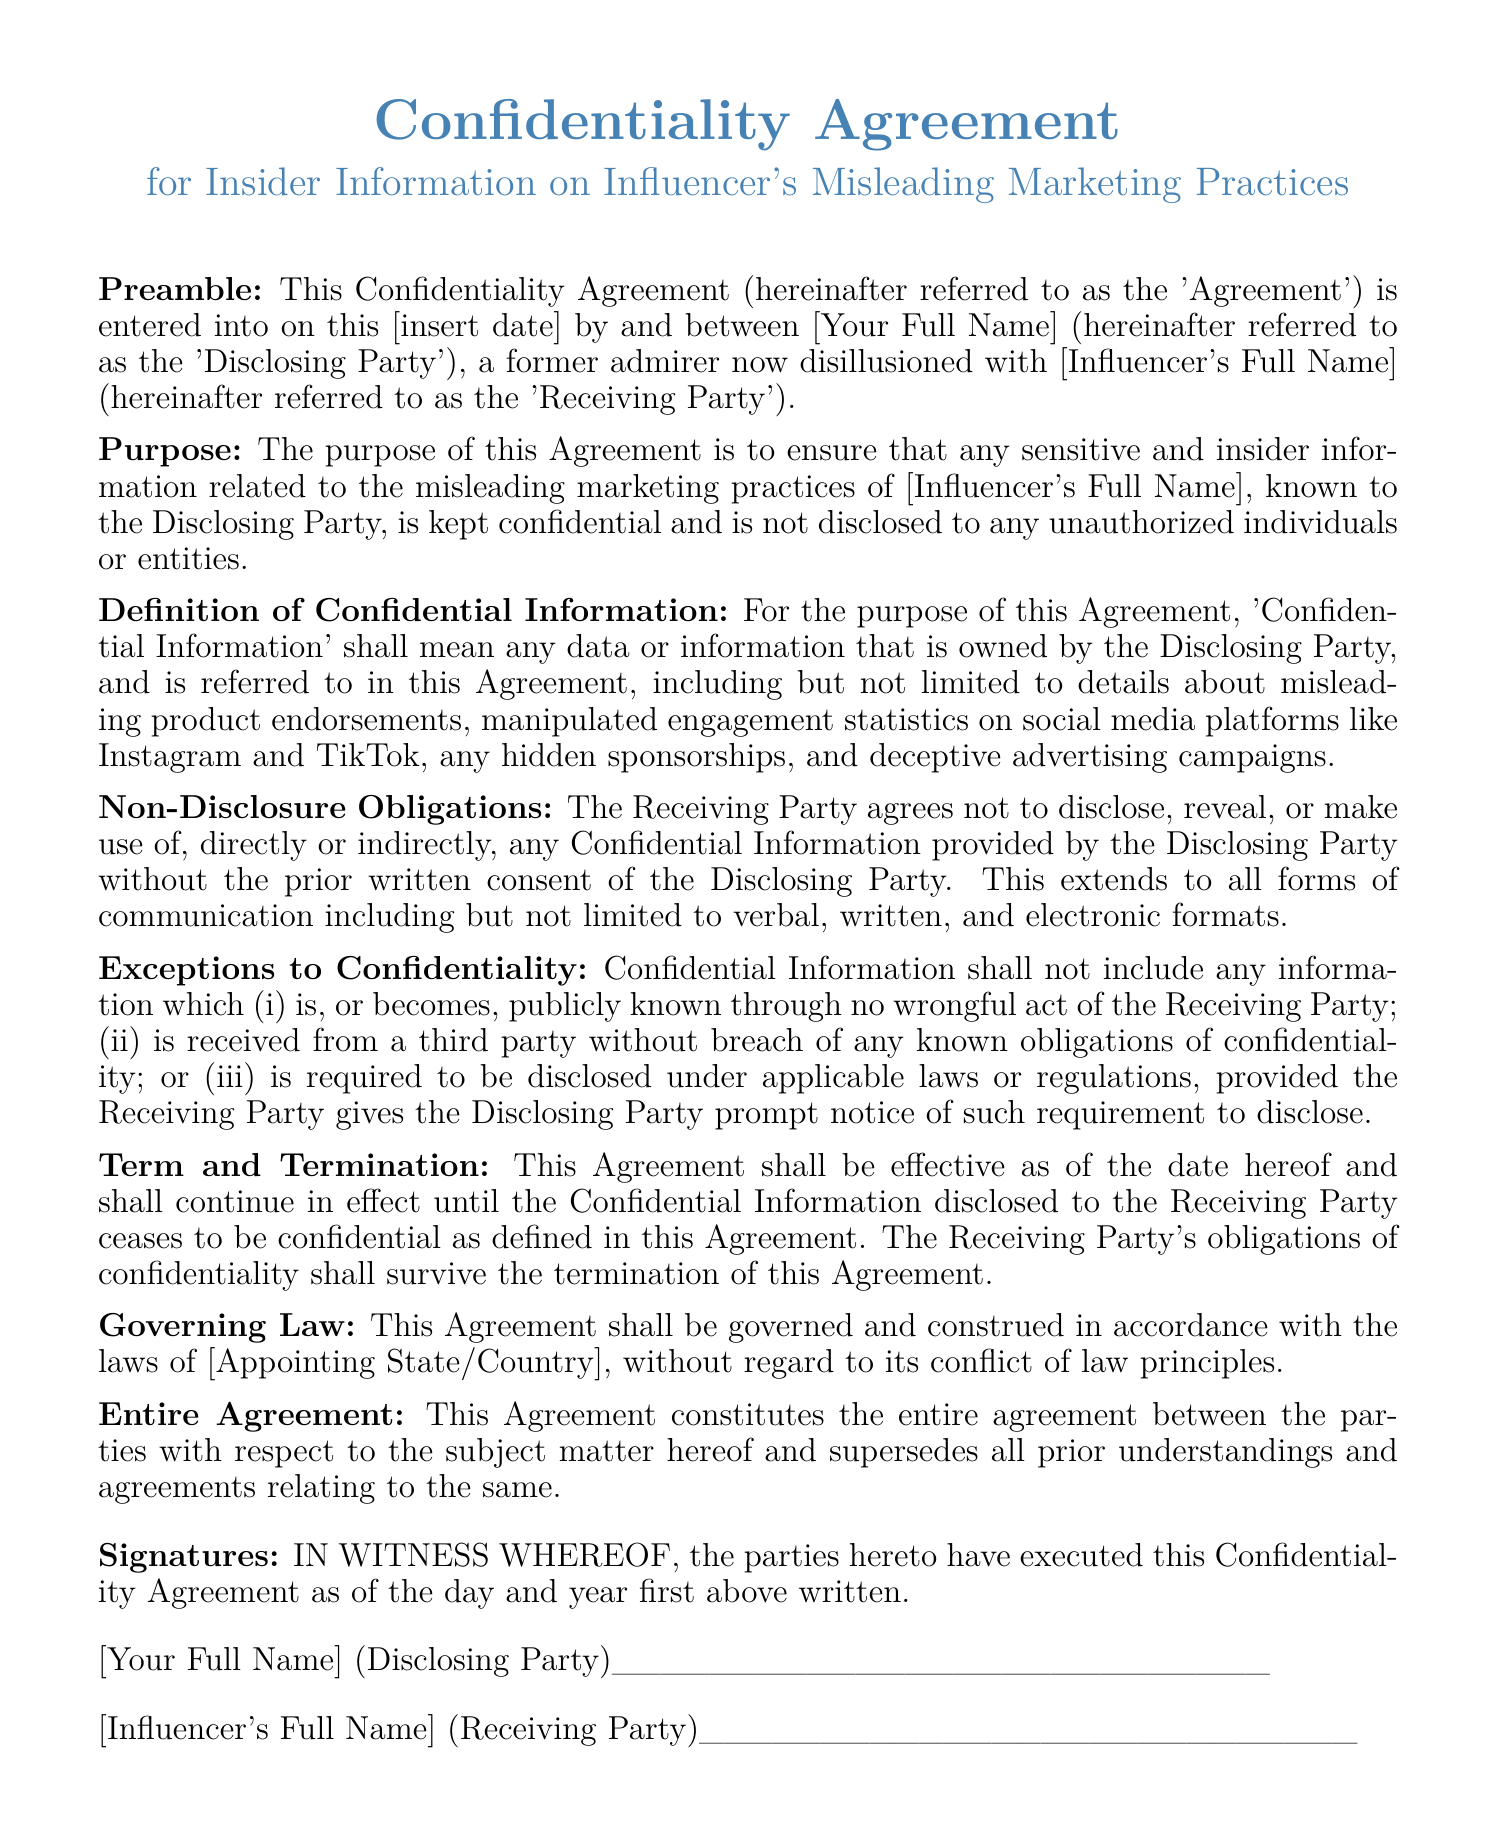What is the title of the document? The title is prominently displayed at the beginning of the document and indicates the nature of the agreement.
Answer: Confidentiality Agreement for Insider Information on Influencer's Misleading Marketing Practices Who is the Disclosing Party? The Disclosing Party is the individual who provides the confidential information, as stated in the preamble.
Answer: [Your Full Name] Who is the Receiving Party? The Receiving Party is the individual receiving the confidential information, also noted in the preamble.
Answer: [Influencer's Full Name] What must the Receiving Party not do with Confidential Information? The document outlines the obligations of the Receiving Party regarding the Confidential Information.
Answer: Disclose What are the exceptions to confidentiality? These exceptions are outlined in a dedicated section of the document, detailing conditions under which confidentiality does not apply.
Answer: Publicly known, received from a third party, required by law What governs this Agreement? The governing law is mentioned in the relevant section of the document, indicating the legal framework for the Agreement.
Answer: Laws of [Appointing State/Country] How long does the Agreement remain in effect? The duration of the Agreement is specified in the Term and Termination section, indicating the continuity of its terms.
Answer: Until Confidential Information ceases to be confidential What does this Agreement supersede? The document clarifies what this agreement replaces in regard to previous arrangements or agreements.
Answer: All prior understandings and agreements 